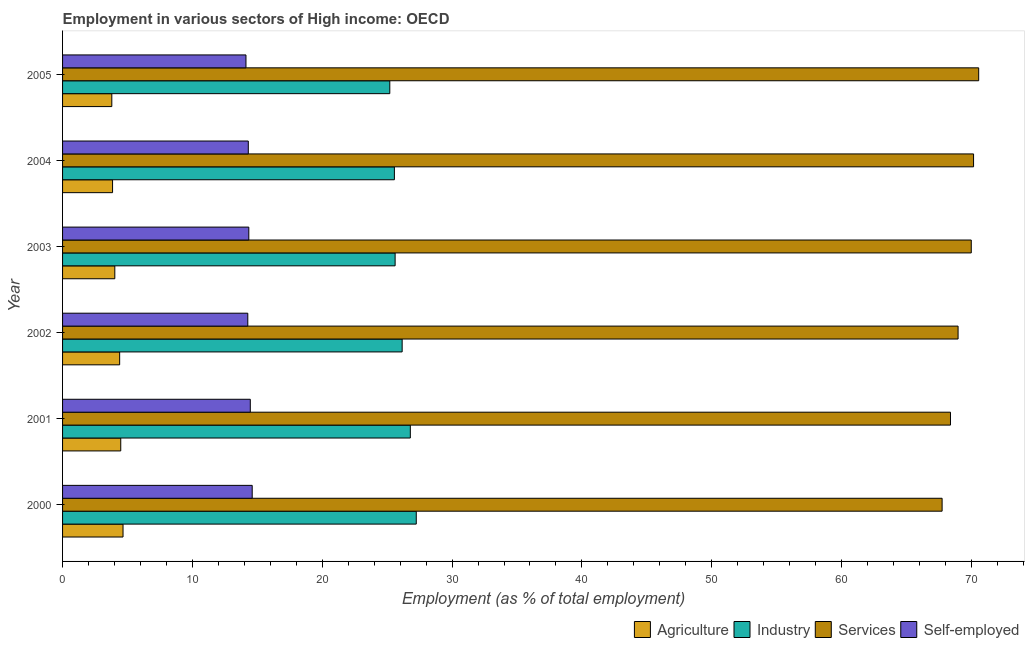How many groups of bars are there?
Offer a very short reply. 6. Are the number of bars on each tick of the Y-axis equal?
Provide a short and direct response. Yes. How many bars are there on the 4th tick from the bottom?
Your response must be concise. 4. What is the percentage of workers in agriculture in 2005?
Keep it short and to the point. 3.79. Across all years, what is the maximum percentage of workers in agriculture?
Your answer should be compact. 4.66. Across all years, what is the minimum percentage of workers in industry?
Offer a terse response. 25.2. What is the total percentage of self employed workers in the graph?
Keep it short and to the point. 86.11. What is the difference between the percentage of workers in services in 2000 and that in 2003?
Provide a short and direct response. -2.25. What is the difference between the percentage of workers in services in 2002 and the percentage of workers in industry in 2001?
Offer a very short reply. 42.19. What is the average percentage of workers in industry per year?
Provide a succinct answer. 26.09. In the year 2002, what is the difference between the percentage of workers in industry and percentage of workers in services?
Keep it short and to the point. -42.82. What is the ratio of the percentage of workers in agriculture in 2000 to that in 2004?
Provide a short and direct response. 1.21. Is the percentage of workers in agriculture in 2000 less than that in 2003?
Offer a very short reply. No. What is the difference between the highest and the second highest percentage of workers in industry?
Give a very brief answer. 0.46. What is the difference between the highest and the lowest percentage of workers in agriculture?
Make the answer very short. 0.86. Is it the case that in every year, the sum of the percentage of workers in agriculture and percentage of workers in services is greater than the sum of percentage of self employed workers and percentage of workers in industry?
Ensure brevity in your answer.  Yes. What does the 2nd bar from the top in 2003 represents?
Keep it short and to the point. Services. What does the 2nd bar from the bottom in 2000 represents?
Offer a terse response. Industry. Is it the case that in every year, the sum of the percentage of workers in agriculture and percentage of workers in industry is greater than the percentage of workers in services?
Offer a terse response. No. How many bars are there?
Make the answer very short. 24. Are all the bars in the graph horizontal?
Your response must be concise. Yes. How many years are there in the graph?
Provide a succinct answer. 6. Does the graph contain any zero values?
Your answer should be compact. No. Does the graph contain grids?
Provide a succinct answer. No. How many legend labels are there?
Your response must be concise. 4. How are the legend labels stacked?
Offer a terse response. Horizontal. What is the title of the graph?
Your answer should be compact. Employment in various sectors of High income: OECD. Does "Quality Certification" appear as one of the legend labels in the graph?
Your answer should be compact. No. What is the label or title of the X-axis?
Your answer should be very brief. Employment (as % of total employment). What is the label or title of the Y-axis?
Offer a terse response. Year. What is the Employment (as % of total employment) of Agriculture in 2000?
Provide a short and direct response. 4.66. What is the Employment (as % of total employment) in Industry in 2000?
Provide a short and direct response. 27.24. What is the Employment (as % of total employment) of Services in 2000?
Give a very brief answer. 67.74. What is the Employment (as % of total employment) of Self-employed in 2000?
Provide a succinct answer. 14.61. What is the Employment (as % of total employment) of Agriculture in 2001?
Your response must be concise. 4.48. What is the Employment (as % of total employment) in Industry in 2001?
Provide a succinct answer. 26.78. What is the Employment (as % of total employment) in Services in 2001?
Your answer should be compact. 68.39. What is the Employment (as % of total employment) in Self-employed in 2001?
Offer a very short reply. 14.46. What is the Employment (as % of total employment) of Agriculture in 2002?
Give a very brief answer. 4.4. What is the Employment (as % of total employment) of Industry in 2002?
Give a very brief answer. 26.16. What is the Employment (as % of total employment) in Services in 2002?
Make the answer very short. 68.97. What is the Employment (as % of total employment) in Self-employed in 2002?
Keep it short and to the point. 14.27. What is the Employment (as % of total employment) of Agriculture in 2003?
Offer a terse response. 4.02. What is the Employment (as % of total employment) of Industry in 2003?
Ensure brevity in your answer.  25.61. What is the Employment (as % of total employment) of Services in 2003?
Your answer should be compact. 69.99. What is the Employment (as % of total employment) of Self-employed in 2003?
Provide a succinct answer. 14.34. What is the Employment (as % of total employment) of Agriculture in 2004?
Offer a terse response. 3.85. What is the Employment (as % of total employment) in Industry in 2004?
Your answer should be compact. 25.56. What is the Employment (as % of total employment) in Services in 2004?
Your response must be concise. 70.17. What is the Employment (as % of total employment) in Self-employed in 2004?
Provide a short and direct response. 14.3. What is the Employment (as % of total employment) of Agriculture in 2005?
Offer a very short reply. 3.79. What is the Employment (as % of total employment) in Industry in 2005?
Offer a terse response. 25.2. What is the Employment (as % of total employment) in Services in 2005?
Keep it short and to the point. 70.56. What is the Employment (as % of total employment) in Self-employed in 2005?
Your answer should be compact. 14.13. Across all years, what is the maximum Employment (as % of total employment) of Agriculture?
Provide a succinct answer. 4.66. Across all years, what is the maximum Employment (as % of total employment) of Industry?
Ensure brevity in your answer.  27.24. Across all years, what is the maximum Employment (as % of total employment) in Services?
Give a very brief answer. 70.56. Across all years, what is the maximum Employment (as % of total employment) in Self-employed?
Provide a short and direct response. 14.61. Across all years, what is the minimum Employment (as % of total employment) of Agriculture?
Your answer should be very brief. 3.79. Across all years, what is the minimum Employment (as % of total employment) in Industry?
Your answer should be very brief. 25.2. Across all years, what is the minimum Employment (as % of total employment) in Services?
Your answer should be compact. 67.74. Across all years, what is the minimum Employment (as % of total employment) of Self-employed?
Make the answer very short. 14.13. What is the total Employment (as % of total employment) of Agriculture in the graph?
Offer a very short reply. 25.2. What is the total Employment (as % of total employment) of Industry in the graph?
Provide a succinct answer. 156.56. What is the total Employment (as % of total employment) in Services in the graph?
Offer a very short reply. 415.82. What is the total Employment (as % of total employment) of Self-employed in the graph?
Offer a terse response. 86.11. What is the difference between the Employment (as % of total employment) in Agriculture in 2000 and that in 2001?
Offer a very short reply. 0.18. What is the difference between the Employment (as % of total employment) in Industry in 2000 and that in 2001?
Keep it short and to the point. 0.46. What is the difference between the Employment (as % of total employment) of Services in 2000 and that in 2001?
Your answer should be compact. -0.64. What is the difference between the Employment (as % of total employment) in Self-employed in 2000 and that in 2001?
Your answer should be very brief. 0.15. What is the difference between the Employment (as % of total employment) of Agriculture in 2000 and that in 2002?
Provide a succinct answer. 0.26. What is the difference between the Employment (as % of total employment) of Industry in 2000 and that in 2002?
Your answer should be compact. 1.09. What is the difference between the Employment (as % of total employment) of Services in 2000 and that in 2002?
Provide a succinct answer. -1.23. What is the difference between the Employment (as % of total employment) of Self-employed in 2000 and that in 2002?
Your answer should be compact. 0.34. What is the difference between the Employment (as % of total employment) in Agriculture in 2000 and that in 2003?
Give a very brief answer. 0.63. What is the difference between the Employment (as % of total employment) in Industry in 2000 and that in 2003?
Ensure brevity in your answer.  1.63. What is the difference between the Employment (as % of total employment) of Services in 2000 and that in 2003?
Make the answer very short. -2.25. What is the difference between the Employment (as % of total employment) in Self-employed in 2000 and that in 2003?
Offer a very short reply. 0.26. What is the difference between the Employment (as % of total employment) in Agriculture in 2000 and that in 2004?
Your answer should be compact. 0.81. What is the difference between the Employment (as % of total employment) in Industry in 2000 and that in 2004?
Your answer should be very brief. 1.69. What is the difference between the Employment (as % of total employment) in Services in 2000 and that in 2004?
Give a very brief answer. -2.42. What is the difference between the Employment (as % of total employment) in Self-employed in 2000 and that in 2004?
Provide a short and direct response. 0.3. What is the difference between the Employment (as % of total employment) in Agriculture in 2000 and that in 2005?
Provide a short and direct response. 0.86. What is the difference between the Employment (as % of total employment) in Industry in 2000 and that in 2005?
Give a very brief answer. 2.04. What is the difference between the Employment (as % of total employment) in Services in 2000 and that in 2005?
Offer a terse response. -2.82. What is the difference between the Employment (as % of total employment) of Self-employed in 2000 and that in 2005?
Your response must be concise. 0.48. What is the difference between the Employment (as % of total employment) in Agriculture in 2001 and that in 2002?
Ensure brevity in your answer.  0.08. What is the difference between the Employment (as % of total employment) of Industry in 2001 and that in 2002?
Ensure brevity in your answer.  0.63. What is the difference between the Employment (as % of total employment) of Services in 2001 and that in 2002?
Provide a short and direct response. -0.58. What is the difference between the Employment (as % of total employment) of Self-employed in 2001 and that in 2002?
Offer a very short reply. 0.19. What is the difference between the Employment (as % of total employment) in Agriculture in 2001 and that in 2003?
Your answer should be very brief. 0.46. What is the difference between the Employment (as % of total employment) in Industry in 2001 and that in 2003?
Offer a terse response. 1.17. What is the difference between the Employment (as % of total employment) of Services in 2001 and that in 2003?
Offer a very short reply. -1.6. What is the difference between the Employment (as % of total employment) in Self-employed in 2001 and that in 2003?
Your response must be concise. 0.11. What is the difference between the Employment (as % of total employment) of Agriculture in 2001 and that in 2004?
Offer a very short reply. 0.63. What is the difference between the Employment (as % of total employment) in Industry in 2001 and that in 2004?
Make the answer very short. 1.23. What is the difference between the Employment (as % of total employment) in Services in 2001 and that in 2004?
Your response must be concise. -1.78. What is the difference between the Employment (as % of total employment) in Self-employed in 2001 and that in 2004?
Offer a very short reply. 0.15. What is the difference between the Employment (as % of total employment) of Agriculture in 2001 and that in 2005?
Ensure brevity in your answer.  0.69. What is the difference between the Employment (as % of total employment) of Industry in 2001 and that in 2005?
Ensure brevity in your answer.  1.58. What is the difference between the Employment (as % of total employment) in Services in 2001 and that in 2005?
Offer a terse response. -2.17. What is the difference between the Employment (as % of total employment) of Self-employed in 2001 and that in 2005?
Keep it short and to the point. 0.33. What is the difference between the Employment (as % of total employment) of Agriculture in 2002 and that in 2003?
Ensure brevity in your answer.  0.37. What is the difference between the Employment (as % of total employment) in Industry in 2002 and that in 2003?
Your response must be concise. 0.54. What is the difference between the Employment (as % of total employment) in Services in 2002 and that in 2003?
Your response must be concise. -1.02. What is the difference between the Employment (as % of total employment) in Self-employed in 2002 and that in 2003?
Offer a very short reply. -0.08. What is the difference between the Employment (as % of total employment) in Agriculture in 2002 and that in 2004?
Your answer should be compact. 0.55. What is the difference between the Employment (as % of total employment) in Industry in 2002 and that in 2004?
Your response must be concise. 0.6. What is the difference between the Employment (as % of total employment) of Services in 2002 and that in 2004?
Offer a very short reply. -1.19. What is the difference between the Employment (as % of total employment) in Self-employed in 2002 and that in 2004?
Provide a short and direct response. -0.04. What is the difference between the Employment (as % of total employment) in Agriculture in 2002 and that in 2005?
Ensure brevity in your answer.  0.6. What is the difference between the Employment (as % of total employment) of Industry in 2002 and that in 2005?
Keep it short and to the point. 0.95. What is the difference between the Employment (as % of total employment) in Services in 2002 and that in 2005?
Offer a terse response. -1.59. What is the difference between the Employment (as % of total employment) of Self-employed in 2002 and that in 2005?
Make the answer very short. 0.14. What is the difference between the Employment (as % of total employment) of Agriculture in 2003 and that in 2004?
Provide a short and direct response. 0.17. What is the difference between the Employment (as % of total employment) in Industry in 2003 and that in 2004?
Your answer should be compact. 0.06. What is the difference between the Employment (as % of total employment) in Services in 2003 and that in 2004?
Give a very brief answer. -0.18. What is the difference between the Employment (as % of total employment) of Self-employed in 2003 and that in 2004?
Provide a short and direct response. 0.04. What is the difference between the Employment (as % of total employment) of Agriculture in 2003 and that in 2005?
Your response must be concise. 0.23. What is the difference between the Employment (as % of total employment) of Industry in 2003 and that in 2005?
Provide a short and direct response. 0.41. What is the difference between the Employment (as % of total employment) in Services in 2003 and that in 2005?
Ensure brevity in your answer.  -0.57. What is the difference between the Employment (as % of total employment) in Self-employed in 2003 and that in 2005?
Provide a short and direct response. 0.22. What is the difference between the Employment (as % of total employment) in Agriculture in 2004 and that in 2005?
Provide a succinct answer. 0.06. What is the difference between the Employment (as % of total employment) in Industry in 2004 and that in 2005?
Provide a short and direct response. 0.35. What is the difference between the Employment (as % of total employment) of Services in 2004 and that in 2005?
Keep it short and to the point. -0.39. What is the difference between the Employment (as % of total employment) in Self-employed in 2004 and that in 2005?
Offer a very short reply. 0.18. What is the difference between the Employment (as % of total employment) of Agriculture in 2000 and the Employment (as % of total employment) of Industry in 2001?
Make the answer very short. -22.13. What is the difference between the Employment (as % of total employment) in Agriculture in 2000 and the Employment (as % of total employment) in Services in 2001?
Ensure brevity in your answer.  -63.73. What is the difference between the Employment (as % of total employment) of Agriculture in 2000 and the Employment (as % of total employment) of Self-employed in 2001?
Keep it short and to the point. -9.8. What is the difference between the Employment (as % of total employment) in Industry in 2000 and the Employment (as % of total employment) in Services in 2001?
Ensure brevity in your answer.  -41.15. What is the difference between the Employment (as % of total employment) in Industry in 2000 and the Employment (as % of total employment) in Self-employed in 2001?
Your answer should be very brief. 12.78. What is the difference between the Employment (as % of total employment) of Services in 2000 and the Employment (as % of total employment) of Self-employed in 2001?
Provide a short and direct response. 53.28. What is the difference between the Employment (as % of total employment) in Agriculture in 2000 and the Employment (as % of total employment) in Industry in 2002?
Keep it short and to the point. -21.5. What is the difference between the Employment (as % of total employment) in Agriculture in 2000 and the Employment (as % of total employment) in Services in 2002?
Your response must be concise. -64.32. What is the difference between the Employment (as % of total employment) in Agriculture in 2000 and the Employment (as % of total employment) in Self-employed in 2002?
Provide a succinct answer. -9.61. What is the difference between the Employment (as % of total employment) in Industry in 2000 and the Employment (as % of total employment) in Services in 2002?
Provide a short and direct response. -41.73. What is the difference between the Employment (as % of total employment) in Industry in 2000 and the Employment (as % of total employment) in Self-employed in 2002?
Make the answer very short. 12.98. What is the difference between the Employment (as % of total employment) in Services in 2000 and the Employment (as % of total employment) in Self-employed in 2002?
Offer a terse response. 53.48. What is the difference between the Employment (as % of total employment) in Agriculture in 2000 and the Employment (as % of total employment) in Industry in 2003?
Make the answer very short. -20.96. What is the difference between the Employment (as % of total employment) in Agriculture in 2000 and the Employment (as % of total employment) in Services in 2003?
Your response must be concise. -65.33. What is the difference between the Employment (as % of total employment) of Agriculture in 2000 and the Employment (as % of total employment) of Self-employed in 2003?
Your answer should be very brief. -9.69. What is the difference between the Employment (as % of total employment) in Industry in 2000 and the Employment (as % of total employment) in Services in 2003?
Offer a terse response. -42.75. What is the difference between the Employment (as % of total employment) of Industry in 2000 and the Employment (as % of total employment) of Self-employed in 2003?
Offer a very short reply. 12.9. What is the difference between the Employment (as % of total employment) of Services in 2000 and the Employment (as % of total employment) of Self-employed in 2003?
Provide a succinct answer. 53.4. What is the difference between the Employment (as % of total employment) of Agriculture in 2000 and the Employment (as % of total employment) of Industry in 2004?
Offer a very short reply. -20.9. What is the difference between the Employment (as % of total employment) in Agriculture in 2000 and the Employment (as % of total employment) in Services in 2004?
Offer a very short reply. -65.51. What is the difference between the Employment (as % of total employment) in Agriculture in 2000 and the Employment (as % of total employment) in Self-employed in 2004?
Provide a succinct answer. -9.65. What is the difference between the Employment (as % of total employment) of Industry in 2000 and the Employment (as % of total employment) of Services in 2004?
Keep it short and to the point. -42.92. What is the difference between the Employment (as % of total employment) in Industry in 2000 and the Employment (as % of total employment) in Self-employed in 2004?
Offer a terse response. 12.94. What is the difference between the Employment (as % of total employment) in Services in 2000 and the Employment (as % of total employment) in Self-employed in 2004?
Keep it short and to the point. 53.44. What is the difference between the Employment (as % of total employment) in Agriculture in 2000 and the Employment (as % of total employment) in Industry in 2005?
Make the answer very short. -20.55. What is the difference between the Employment (as % of total employment) in Agriculture in 2000 and the Employment (as % of total employment) in Services in 2005?
Offer a terse response. -65.9. What is the difference between the Employment (as % of total employment) in Agriculture in 2000 and the Employment (as % of total employment) in Self-employed in 2005?
Provide a short and direct response. -9.47. What is the difference between the Employment (as % of total employment) of Industry in 2000 and the Employment (as % of total employment) of Services in 2005?
Keep it short and to the point. -43.32. What is the difference between the Employment (as % of total employment) in Industry in 2000 and the Employment (as % of total employment) in Self-employed in 2005?
Give a very brief answer. 13.12. What is the difference between the Employment (as % of total employment) of Services in 2000 and the Employment (as % of total employment) of Self-employed in 2005?
Offer a terse response. 53.62. What is the difference between the Employment (as % of total employment) in Agriculture in 2001 and the Employment (as % of total employment) in Industry in 2002?
Keep it short and to the point. -21.67. What is the difference between the Employment (as % of total employment) of Agriculture in 2001 and the Employment (as % of total employment) of Services in 2002?
Your response must be concise. -64.49. What is the difference between the Employment (as % of total employment) in Agriculture in 2001 and the Employment (as % of total employment) in Self-employed in 2002?
Your response must be concise. -9.79. What is the difference between the Employment (as % of total employment) in Industry in 2001 and the Employment (as % of total employment) in Services in 2002?
Ensure brevity in your answer.  -42.19. What is the difference between the Employment (as % of total employment) of Industry in 2001 and the Employment (as % of total employment) of Self-employed in 2002?
Make the answer very short. 12.52. What is the difference between the Employment (as % of total employment) in Services in 2001 and the Employment (as % of total employment) in Self-employed in 2002?
Offer a terse response. 54.12. What is the difference between the Employment (as % of total employment) of Agriculture in 2001 and the Employment (as % of total employment) of Industry in 2003?
Provide a short and direct response. -21.13. What is the difference between the Employment (as % of total employment) in Agriculture in 2001 and the Employment (as % of total employment) in Services in 2003?
Ensure brevity in your answer.  -65.51. What is the difference between the Employment (as % of total employment) of Agriculture in 2001 and the Employment (as % of total employment) of Self-employed in 2003?
Keep it short and to the point. -9.86. What is the difference between the Employment (as % of total employment) of Industry in 2001 and the Employment (as % of total employment) of Services in 2003?
Your answer should be compact. -43.2. What is the difference between the Employment (as % of total employment) in Industry in 2001 and the Employment (as % of total employment) in Self-employed in 2003?
Make the answer very short. 12.44. What is the difference between the Employment (as % of total employment) in Services in 2001 and the Employment (as % of total employment) in Self-employed in 2003?
Provide a short and direct response. 54.04. What is the difference between the Employment (as % of total employment) of Agriculture in 2001 and the Employment (as % of total employment) of Industry in 2004?
Your answer should be very brief. -21.08. What is the difference between the Employment (as % of total employment) of Agriculture in 2001 and the Employment (as % of total employment) of Services in 2004?
Give a very brief answer. -65.69. What is the difference between the Employment (as % of total employment) in Agriculture in 2001 and the Employment (as % of total employment) in Self-employed in 2004?
Your response must be concise. -9.82. What is the difference between the Employment (as % of total employment) of Industry in 2001 and the Employment (as % of total employment) of Services in 2004?
Give a very brief answer. -43.38. What is the difference between the Employment (as % of total employment) of Industry in 2001 and the Employment (as % of total employment) of Self-employed in 2004?
Offer a very short reply. 12.48. What is the difference between the Employment (as % of total employment) of Services in 2001 and the Employment (as % of total employment) of Self-employed in 2004?
Ensure brevity in your answer.  54.08. What is the difference between the Employment (as % of total employment) in Agriculture in 2001 and the Employment (as % of total employment) in Industry in 2005?
Your answer should be compact. -20.72. What is the difference between the Employment (as % of total employment) of Agriculture in 2001 and the Employment (as % of total employment) of Services in 2005?
Provide a succinct answer. -66.08. What is the difference between the Employment (as % of total employment) in Agriculture in 2001 and the Employment (as % of total employment) in Self-employed in 2005?
Your answer should be compact. -9.64. What is the difference between the Employment (as % of total employment) of Industry in 2001 and the Employment (as % of total employment) of Services in 2005?
Your response must be concise. -43.78. What is the difference between the Employment (as % of total employment) in Industry in 2001 and the Employment (as % of total employment) in Self-employed in 2005?
Your answer should be compact. 12.66. What is the difference between the Employment (as % of total employment) of Services in 2001 and the Employment (as % of total employment) of Self-employed in 2005?
Offer a terse response. 54.26. What is the difference between the Employment (as % of total employment) of Agriculture in 2002 and the Employment (as % of total employment) of Industry in 2003?
Give a very brief answer. -21.22. What is the difference between the Employment (as % of total employment) of Agriculture in 2002 and the Employment (as % of total employment) of Services in 2003?
Provide a short and direct response. -65.59. What is the difference between the Employment (as % of total employment) in Agriculture in 2002 and the Employment (as % of total employment) in Self-employed in 2003?
Your response must be concise. -9.95. What is the difference between the Employment (as % of total employment) of Industry in 2002 and the Employment (as % of total employment) of Services in 2003?
Ensure brevity in your answer.  -43.83. What is the difference between the Employment (as % of total employment) of Industry in 2002 and the Employment (as % of total employment) of Self-employed in 2003?
Your answer should be very brief. 11.81. What is the difference between the Employment (as % of total employment) in Services in 2002 and the Employment (as % of total employment) in Self-employed in 2003?
Keep it short and to the point. 54.63. What is the difference between the Employment (as % of total employment) in Agriculture in 2002 and the Employment (as % of total employment) in Industry in 2004?
Give a very brief answer. -21.16. What is the difference between the Employment (as % of total employment) of Agriculture in 2002 and the Employment (as % of total employment) of Services in 2004?
Offer a very short reply. -65.77. What is the difference between the Employment (as % of total employment) of Agriculture in 2002 and the Employment (as % of total employment) of Self-employed in 2004?
Your answer should be compact. -9.91. What is the difference between the Employment (as % of total employment) of Industry in 2002 and the Employment (as % of total employment) of Services in 2004?
Your response must be concise. -44.01. What is the difference between the Employment (as % of total employment) of Industry in 2002 and the Employment (as % of total employment) of Self-employed in 2004?
Keep it short and to the point. 11.85. What is the difference between the Employment (as % of total employment) in Services in 2002 and the Employment (as % of total employment) in Self-employed in 2004?
Keep it short and to the point. 54.67. What is the difference between the Employment (as % of total employment) of Agriculture in 2002 and the Employment (as % of total employment) of Industry in 2005?
Offer a very short reply. -20.81. What is the difference between the Employment (as % of total employment) in Agriculture in 2002 and the Employment (as % of total employment) in Services in 2005?
Provide a succinct answer. -66.16. What is the difference between the Employment (as % of total employment) in Agriculture in 2002 and the Employment (as % of total employment) in Self-employed in 2005?
Your response must be concise. -9.73. What is the difference between the Employment (as % of total employment) of Industry in 2002 and the Employment (as % of total employment) of Services in 2005?
Make the answer very short. -44.41. What is the difference between the Employment (as % of total employment) of Industry in 2002 and the Employment (as % of total employment) of Self-employed in 2005?
Provide a succinct answer. 12.03. What is the difference between the Employment (as % of total employment) in Services in 2002 and the Employment (as % of total employment) in Self-employed in 2005?
Provide a succinct answer. 54.85. What is the difference between the Employment (as % of total employment) of Agriculture in 2003 and the Employment (as % of total employment) of Industry in 2004?
Your answer should be very brief. -21.53. What is the difference between the Employment (as % of total employment) of Agriculture in 2003 and the Employment (as % of total employment) of Services in 2004?
Provide a short and direct response. -66.14. What is the difference between the Employment (as % of total employment) in Agriculture in 2003 and the Employment (as % of total employment) in Self-employed in 2004?
Offer a terse response. -10.28. What is the difference between the Employment (as % of total employment) of Industry in 2003 and the Employment (as % of total employment) of Services in 2004?
Offer a very short reply. -44.55. What is the difference between the Employment (as % of total employment) of Industry in 2003 and the Employment (as % of total employment) of Self-employed in 2004?
Provide a succinct answer. 11.31. What is the difference between the Employment (as % of total employment) of Services in 2003 and the Employment (as % of total employment) of Self-employed in 2004?
Your response must be concise. 55.68. What is the difference between the Employment (as % of total employment) in Agriculture in 2003 and the Employment (as % of total employment) in Industry in 2005?
Keep it short and to the point. -21.18. What is the difference between the Employment (as % of total employment) in Agriculture in 2003 and the Employment (as % of total employment) in Services in 2005?
Ensure brevity in your answer.  -66.54. What is the difference between the Employment (as % of total employment) of Agriculture in 2003 and the Employment (as % of total employment) of Self-employed in 2005?
Offer a terse response. -10.1. What is the difference between the Employment (as % of total employment) of Industry in 2003 and the Employment (as % of total employment) of Services in 2005?
Give a very brief answer. -44.95. What is the difference between the Employment (as % of total employment) of Industry in 2003 and the Employment (as % of total employment) of Self-employed in 2005?
Make the answer very short. 11.49. What is the difference between the Employment (as % of total employment) in Services in 2003 and the Employment (as % of total employment) in Self-employed in 2005?
Your answer should be very brief. 55.86. What is the difference between the Employment (as % of total employment) in Agriculture in 2004 and the Employment (as % of total employment) in Industry in 2005?
Make the answer very short. -21.35. What is the difference between the Employment (as % of total employment) of Agriculture in 2004 and the Employment (as % of total employment) of Services in 2005?
Make the answer very short. -66.71. What is the difference between the Employment (as % of total employment) of Agriculture in 2004 and the Employment (as % of total employment) of Self-employed in 2005?
Your answer should be very brief. -10.28. What is the difference between the Employment (as % of total employment) in Industry in 2004 and the Employment (as % of total employment) in Services in 2005?
Keep it short and to the point. -45. What is the difference between the Employment (as % of total employment) in Industry in 2004 and the Employment (as % of total employment) in Self-employed in 2005?
Ensure brevity in your answer.  11.43. What is the difference between the Employment (as % of total employment) of Services in 2004 and the Employment (as % of total employment) of Self-employed in 2005?
Provide a succinct answer. 56.04. What is the average Employment (as % of total employment) of Agriculture per year?
Your answer should be very brief. 4.2. What is the average Employment (as % of total employment) of Industry per year?
Keep it short and to the point. 26.09. What is the average Employment (as % of total employment) in Services per year?
Your answer should be compact. 69.3. What is the average Employment (as % of total employment) in Self-employed per year?
Make the answer very short. 14.35. In the year 2000, what is the difference between the Employment (as % of total employment) in Agriculture and Employment (as % of total employment) in Industry?
Keep it short and to the point. -22.59. In the year 2000, what is the difference between the Employment (as % of total employment) of Agriculture and Employment (as % of total employment) of Services?
Your response must be concise. -63.09. In the year 2000, what is the difference between the Employment (as % of total employment) of Agriculture and Employment (as % of total employment) of Self-employed?
Provide a short and direct response. -9.95. In the year 2000, what is the difference between the Employment (as % of total employment) in Industry and Employment (as % of total employment) in Services?
Give a very brief answer. -40.5. In the year 2000, what is the difference between the Employment (as % of total employment) in Industry and Employment (as % of total employment) in Self-employed?
Provide a succinct answer. 12.64. In the year 2000, what is the difference between the Employment (as % of total employment) in Services and Employment (as % of total employment) in Self-employed?
Your response must be concise. 53.14. In the year 2001, what is the difference between the Employment (as % of total employment) in Agriculture and Employment (as % of total employment) in Industry?
Provide a succinct answer. -22.3. In the year 2001, what is the difference between the Employment (as % of total employment) in Agriculture and Employment (as % of total employment) in Services?
Make the answer very short. -63.91. In the year 2001, what is the difference between the Employment (as % of total employment) in Agriculture and Employment (as % of total employment) in Self-employed?
Your answer should be compact. -9.98. In the year 2001, what is the difference between the Employment (as % of total employment) of Industry and Employment (as % of total employment) of Services?
Offer a terse response. -41.6. In the year 2001, what is the difference between the Employment (as % of total employment) of Industry and Employment (as % of total employment) of Self-employed?
Your answer should be very brief. 12.33. In the year 2001, what is the difference between the Employment (as % of total employment) in Services and Employment (as % of total employment) in Self-employed?
Keep it short and to the point. 53.93. In the year 2002, what is the difference between the Employment (as % of total employment) in Agriculture and Employment (as % of total employment) in Industry?
Give a very brief answer. -21.76. In the year 2002, what is the difference between the Employment (as % of total employment) of Agriculture and Employment (as % of total employment) of Services?
Provide a succinct answer. -64.58. In the year 2002, what is the difference between the Employment (as % of total employment) of Agriculture and Employment (as % of total employment) of Self-employed?
Your answer should be compact. -9.87. In the year 2002, what is the difference between the Employment (as % of total employment) in Industry and Employment (as % of total employment) in Services?
Provide a succinct answer. -42.82. In the year 2002, what is the difference between the Employment (as % of total employment) in Industry and Employment (as % of total employment) in Self-employed?
Your answer should be very brief. 11.89. In the year 2002, what is the difference between the Employment (as % of total employment) in Services and Employment (as % of total employment) in Self-employed?
Offer a terse response. 54.71. In the year 2003, what is the difference between the Employment (as % of total employment) of Agriculture and Employment (as % of total employment) of Industry?
Keep it short and to the point. -21.59. In the year 2003, what is the difference between the Employment (as % of total employment) in Agriculture and Employment (as % of total employment) in Services?
Give a very brief answer. -65.96. In the year 2003, what is the difference between the Employment (as % of total employment) of Agriculture and Employment (as % of total employment) of Self-employed?
Provide a succinct answer. -10.32. In the year 2003, what is the difference between the Employment (as % of total employment) in Industry and Employment (as % of total employment) in Services?
Make the answer very short. -44.38. In the year 2003, what is the difference between the Employment (as % of total employment) of Industry and Employment (as % of total employment) of Self-employed?
Provide a succinct answer. 11.27. In the year 2003, what is the difference between the Employment (as % of total employment) in Services and Employment (as % of total employment) in Self-employed?
Provide a short and direct response. 55.64. In the year 2004, what is the difference between the Employment (as % of total employment) of Agriculture and Employment (as % of total employment) of Industry?
Your answer should be compact. -21.71. In the year 2004, what is the difference between the Employment (as % of total employment) in Agriculture and Employment (as % of total employment) in Services?
Give a very brief answer. -66.32. In the year 2004, what is the difference between the Employment (as % of total employment) in Agriculture and Employment (as % of total employment) in Self-employed?
Offer a terse response. -10.45. In the year 2004, what is the difference between the Employment (as % of total employment) in Industry and Employment (as % of total employment) in Services?
Make the answer very short. -44.61. In the year 2004, what is the difference between the Employment (as % of total employment) in Industry and Employment (as % of total employment) in Self-employed?
Your answer should be compact. 11.25. In the year 2004, what is the difference between the Employment (as % of total employment) in Services and Employment (as % of total employment) in Self-employed?
Provide a short and direct response. 55.86. In the year 2005, what is the difference between the Employment (as % of total employment) of Agriculture and Employment (as % of total employment) of Industry?
Your answer should be very brief. -21.41. In the year 2005, what is the difference between the Employment (as % of total employment) of Agriculture and Employment (as % of total employment) of Services?
Offer a terse response. -66.77. In the year 2005, what is the difference between the Employment (as % of total employment) in Agriculture and Employment (as % of total employment) in Self-employed?
Your answer should be compact. -10.33. In the year 2005, what is the difference between the Employment (as % of total employment) in Industry and Employment (as % of total employment) in Services?
Your answer should be very brief. -45.36. In the year 2005, what is the difference between the Employment (as % of total employment) in Industry and Employment (as % of total employment) in Self-employed?
Provide a short and direct response. 11.08. In the year 2005, what is the difference between the Employment (as % of total employment) of Services and Employment (as % of total employment) of Self-employed?
Offer a terse response. 56.43. What is the ratio of the Employment (as % of total employment) in Agriculture in 2000 to that in 2001?
Keep it short and to the point. 1.04. What is the ratio of the Employment (as % of total employment) of Industry in 2000 to that in 2001?
Make the answer very short. 1.02. What is the ratio of the Employment (as % of total employment) of Services in 2000 to that in 2001?
Your answer should be compact. 0.99. What is the ratio of the Employment (as % of total employment) of Agriculture in 2000 to that in 2002?
Your answer should be very brief. 1.06. What is the ratio of the Employment (as % of total employment) of Industry in 2000 to that in 2002?
Provide a short and direct response. 1.04. What is the ratio of the Employment (as % of total employment) in Services in 2000 to that in 2002?
Your answer should be very brief. 0.98. What is the ratio of the Employment (as % of total employment) of Self-employed in 2000 to that in 2002?
Your answer should be compact. 1.02. What is the ratio of the Employment (as % of total employment) of Agriculture in 2000 to that in 2003?
Your answer should be compact. 1.16. What is the ratio of the Employment (as % of total employment) in Industry in 2000 to that in 2003?
Your answer should be compact. 1.06. What is the ratio of the Employment (as % of total employment) in Services in 2000 to that in 2003?
Keep it short and to the point. 0.97. What is the ratio of the Employment (as % of total employment) in Self-employed in 2000 to that in 2003?
Your response must be concise. 1.02. What is the ratio of the Employment (as % of total employment) of Agriculture in 2000 to that in 2004?
Ensure brevity in your answer.  1.21. What is the ratio of the Employment (as % of total employment) in Industry in 2000 to that in 2004?
Offer a terse response. 1.07. What is the ratio of the Employment (as % of total employment) in Services in 2000 to that in 2004?
Make the answer very short. 0.97. What is the ratio of the Employment (as % of total employment) of Self-employed in 2000 to that in 2004?
Your answer should be compact. 1.02. What is the ratio of the Employment (as % of total employment) in Agriculture in 2000 to that in 2005?
Provide a succinct answer. 1.23. What is the ratio of the Employment (as % of total employment) in Industry in 2000 to that in 2005?
Provide a short and direct response. 1.08. What is the ratio of the Employment (as % of total employment) in Services in 2000 to that in 2005?
Give a very brief answer. 0.96. What is the ratio of the Employment (as % of total employment) of Self-employed in 2000 to that in 2005?
Make the answer very short. 1.03. What is the ratio of the Employment (as % of total employment) in Agriculture in 2001 to that in 2002?
Provide a succinct answer. 1.02. What is the ratio of the Employment (as % of total employment) in Industry in 2001 to that in 2002?
Make the answer very short. 1.02. What is the ratio of the Employment (as % of total employment) of Services in 2001 to that in 2002?
Your answer should be very brief. 0.99. What is the ratio of the Employment (as % of total employment) in Self-employed in 2001 to that in 2002?
Ensure brevity in your answer.  1.01. What is the ratio of the Employment (as % of total employment) of Agriculture in 2001 to that in 2003?
Provide a succinct answer. 1.11. What is the ratio of the Employment (as % of total employment) of Industry in 2001 to that in 2003?
Ensure brevity in your answer.  1.05. What is the ratio of the Employment (as % of total employment) in Services in 2001 to that in 2003?
Offer a terse response. 0.98. What is the ratio of the Employment (as % of total employment) in Self-employed in 2001 to that in 2003?
Make the answer very short. 1.01. What is the ratio of the Employment (as % of total employment) of Agriculture in 2001 to that in 2004?
Provide a succinct answer. 1.16. What is the ratio of the Employment (as % of total employment) in Industry in 2001 to that in 2004?
Your answer should be compact. 1.05. What is the ratio of the Employment (as % of total employment) of Services in 2001 to that in 2004?
Ensure brevity in your answer.  0.97. What is the ratio of the Employment (as % of total employment) in Self-employed in 2001 to that in 2004?
Provide a short and direct response. 1.01. What is the ratio of the Employment (as % of total employment) in Agriculture in 2001 to that in 2005?
Provide a succinct answer. 1.18. What is the ratio of the Employment (as % of total employment) of Industry in 2001 to that in 2005?
Ensure brevity in your answer.  1.06. What is the ratio of the Employment (as % of total employment) in Services in 2001 to that in 2005?
Keep it short and to the point. 0.97. What is the ratio of the Employment (as % of total employment) of Self-employed in 2001 to that in 2005?
Make the answer very short. 1.02. What is the ratio of the Employment (as % of total employment) of Agriculture in 2002 to that in 2003?
Offer a very short reply. 1.09. What is the ratio of the Employment (as % of total employment) of Industry in 2002 to that in 2003?
Make the answer very short. 1.02. What is the ratio of the Employment (as % of total employment) in Services in 2002 to that in 2003?
Your response must be concise. 0.99. What is the ratio of the Employment (as % of total employment) of Agriculture in 2002 to that in 2004?
Provide a succinct answer. 1.14. What is the ratio of the Employment (as % of total employment) of Industry in 2002 to that in 2004?
Give a very brief answer. 1.02. What is the ratio of the Employment (as % of total employment) in Services in 2002 to that in 2004?
Your response must be concise. 0.98. What is the ratio of the Employment (as % of total employment) in Self-employed in 2002 to that in 2004?
Offer a terse response. 1. What is the ratio of the Employment (as % of total employment) in Agriculture in 2002 to that in 2005?
Keep it short and to the point. 1.16. What is the ratio of the Employment (as % of total employment) of Industry in 2002 to that in 2005?
Your answer should be compact. 1.04. What is the ratio of the Employment (as % of total employment) in Services in 2002 to that in 2005?
Offer a terse response. 0.98. What is the ratio of the Employment (as % of total employment) in Agriculture in 2003 to that in 2004?
Ensure brevity in your answer.  1.05. What is the ratio of the Employment (as % of total employment) in Services in 2003 to that in 2004?
Your answer should be compact. 1. What is the ratio of the Employment (as % of total employment) of Self-employed in 2003 to that in 2004?
Give a very brief answer. 1. What is the ratio of the Employment (as % of total employment) in Agriculture in 2003 to that in 2005?
Ensure brevity in your answer.  1.06. What is the ratio of the Employment (as % of total employment) in Industry in 2003 to that in 2005?
Ensure brevity in your answer.  1.02. What is the ratio of the Employment (as % of total employment) in Self-employed in 2003 to that in 2005?
Make the answer very short. 1.02. What is the ratio of the Employment (as % of total employment) in Agriculture in 2004 to that in 2005?
Your answer should be compact. 1.02. What is the ratio of the Employment (as % of total employment) of Self-employed in 2004 to that in 2005?
Make the answer very short. 1.01. What is the difference between the highest and the second highest Employment (as % of total employment) in Agriculture?
Provide a short and direct response. 0.18. What is the difference between the highest and the second highest Employment (as % of total employment) of Industry?
Offer a terse response. 0.46. What is the difference between the highest and the second highest Employment (as % of total employment) in Services?
Ensure brevity in your answer.  0.39. What is the difference between the highest and the second highest Employment (as % of total employment) of Self-employed?
Give a very brief answer. 0.15. What is the difference between the highest and the lowest Employment (as % of total employment) in Agriculture?
Provide a succinct answer. 0.86. What is the difference between the highest and the lowest Employment (as % of total employment) of Industry?
Provide a succinct answer. 2.04. What is the difference between the highest and the lowest Employment (as % of total employment) in Services?
Your response must be concise. 2.82. What is the difference between the highest and the lowest Employment (as % of total employment) of Self-employed?
Provide a short and direct response. 0.48. 